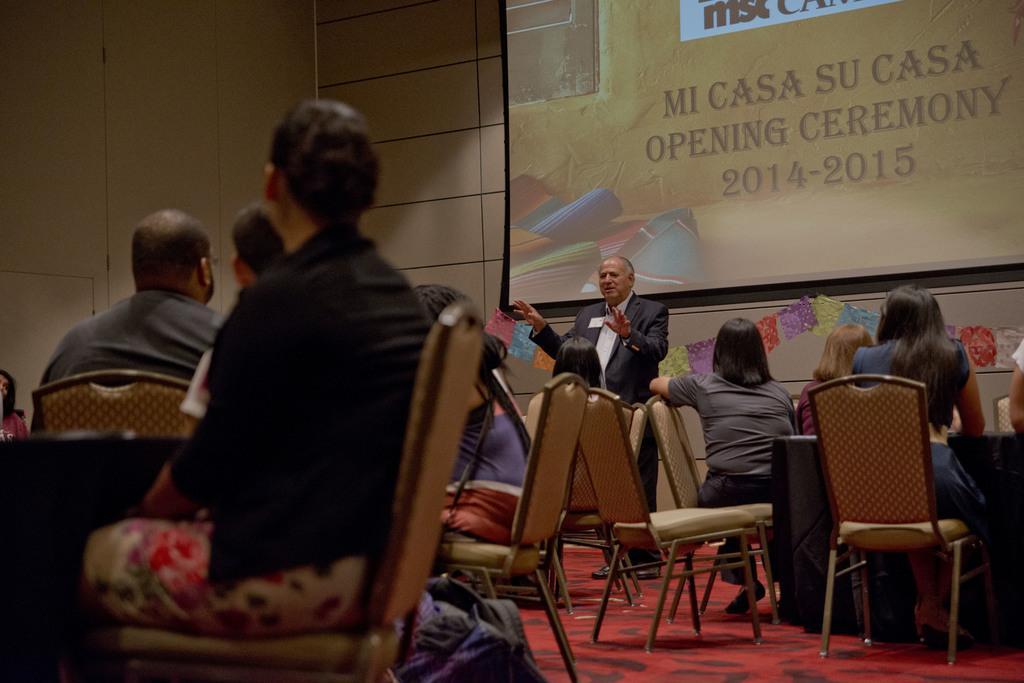Could you give a brief overview of what you see in this image? Most of the persons are sitting on chairs. In-front of this person there is a table. A banner is on wall. Beside this chair there is a bag. This person is standing and wore suit. 